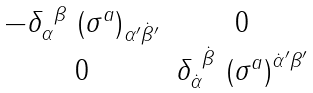Convert formula to latex. <formula><loc_0><loc_0><loc_500><loc_500>\begin{matrix} - \delta _ { \alpha } ^ { \ \beta } \ { ( \sigma ^ { a } ) } _ { \alpha ^ { \prime } { \dot { \beta } } ^ { \prime } } & 0 \\ 0 & \delta _ { \dot { \alpha } } ^ { \ { \dot { \beta } } } \ { ( \sigma ^ { a } ) } ^ { { \dot { \alpha } } ^ { \prime } \beta ^ { \prime } } \end{matrix}</formula> 